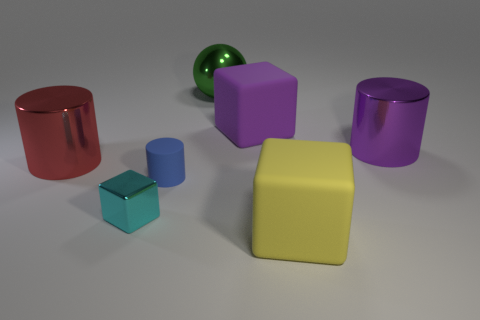Add 1 big green cylinders. How many objects exist? 8 Subtract all blocks. How many objects are left? 4 Subtract all small cyan things. Subtract all tiny blue matte objects. How many objects are left? 5 Add 5 large yellow blocks. How many large yellow blocks are left? 6 Add 3 tiny yellow balls. How many tiny yellow balls exist? 3 Subtract 1 purple cubes. How many objects are left? 6 